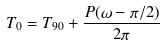Convert formula to latex. <formula><loc_0><loc_0><loc_500><loc_500>T _ { 0 } = T _ { 9 0 } + \frac { P ( \omega - \pi / 2 ) } { 2 \pi }</formula> 